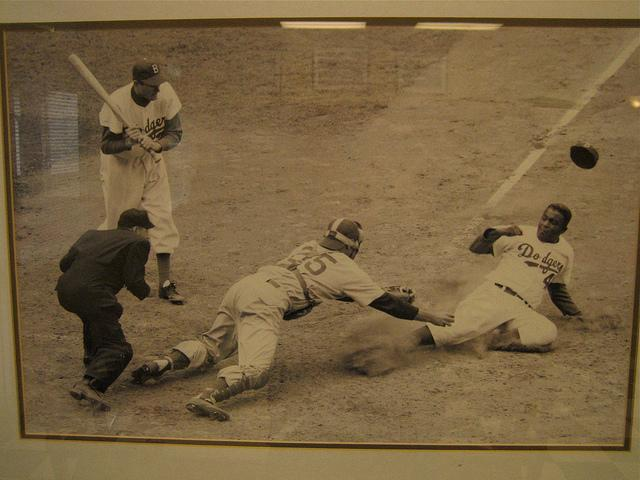What person is sliding? baseball player 